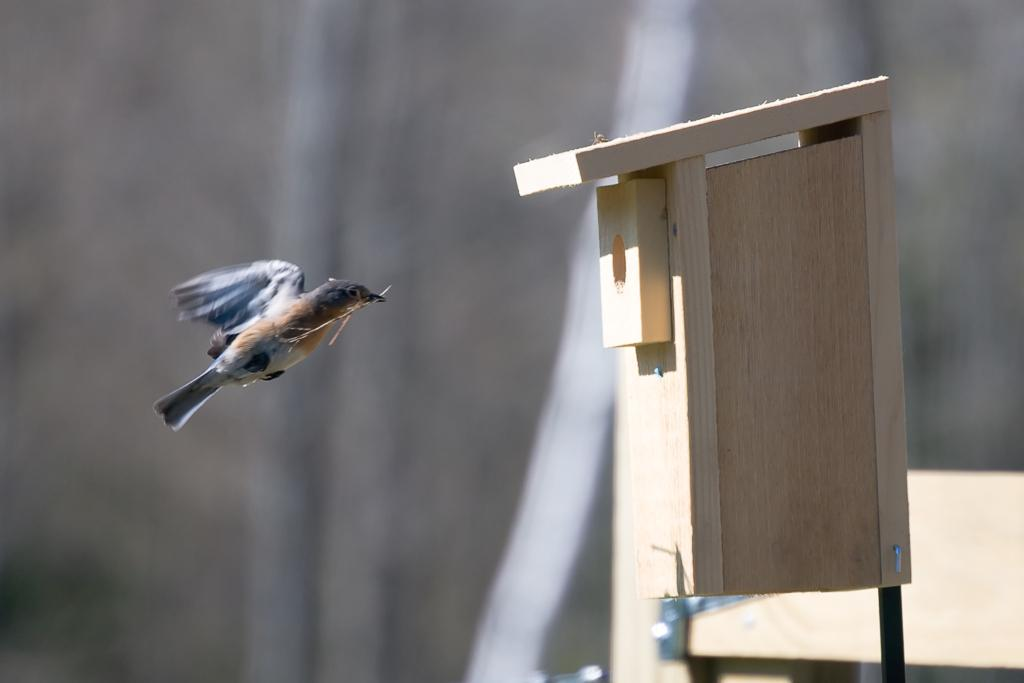What animal can be seen in the image? There is a bird in the image. What is the bird doing in the image? The bird is flying in the air and holding sticks with its beak. Where is the wooden nest located in the image? The wooden nest is on the right side of the image, on a stand. How would you describe the background of the image? The background of the image is blurry. What type of skin can be seen on the bird's feet in the image? There is no visible skin on the bird's feet in the image; only the bird's body and beak are visible. 